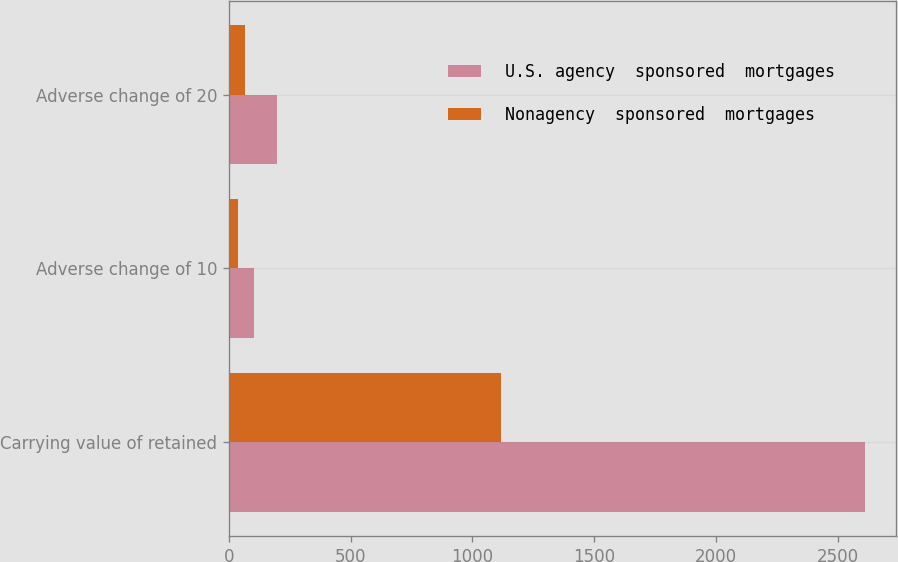<chart> <loc_0><loc_0><loc_500><loc_500><stacked_bar_chart><ecel><fcel>Carrying value of retained<fcel>Adverse change of 10<fcel>Adverse change of 20<nl><fcel>U.S. agency  sponsored  mortgages<fcel>2611<fcel>101<fcel>195<nl><fcel>Nonagency  sponsored  mortgages<fcel>1118<fcel>35<fcel>66<nl></chart> 